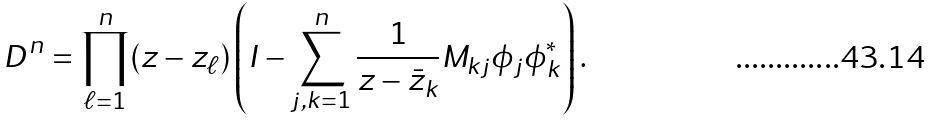<formula> <loc_0><loc_0><loc_500><loc_500>D ^ { n } = \prod _ { \ell = 1 } ^ { n } ( z - z _ { \ell } ) \left ( I - \sum _ { j , k = 1 } ^ { n } \frac { 1 } { z - \bar { z } _ { k } } M _ { k j } \phi _ { j } \phi _ { k } ^ { * } \right ) .</formula> 